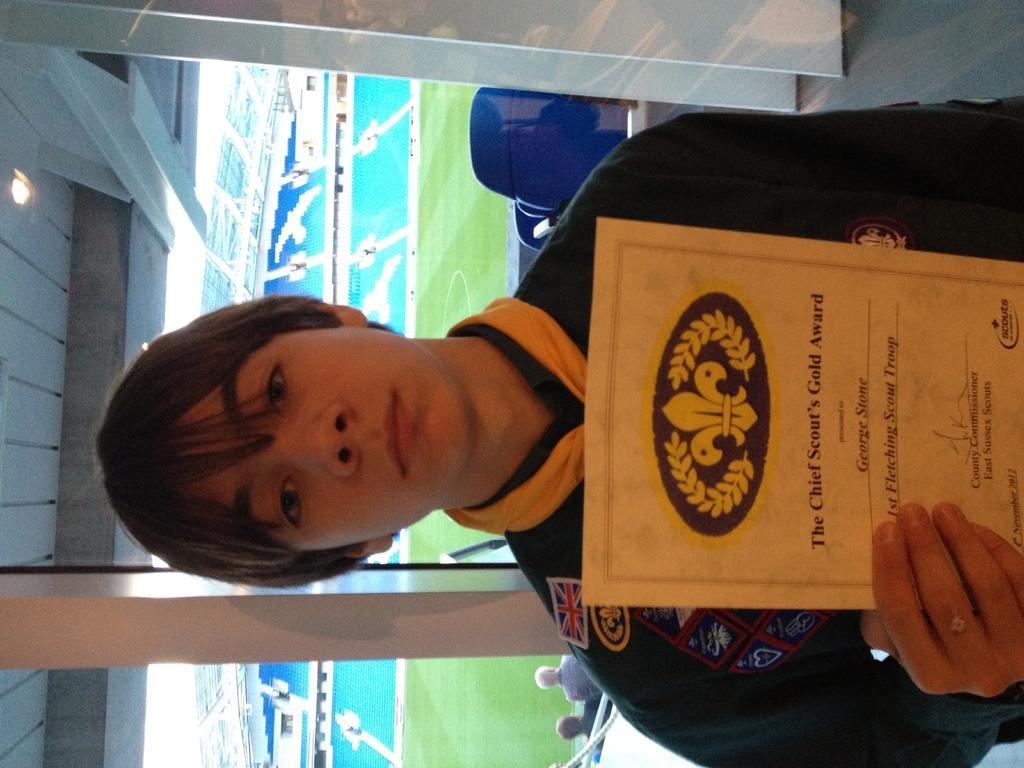Could you give a brief overview of what you see in this image? In this image I can see a boy holding a paper visible in the middle and on the left side I can see a roof, beam and light and in the middle I can see a playground and at the bottom I can see two persons. 